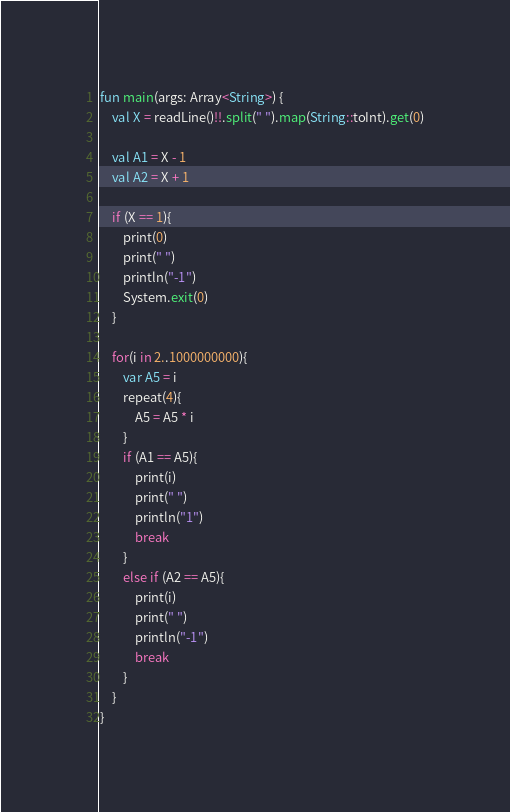Convert code to text. <code><loc_0><loc_0><loc_500><loc_500><_Kotlin_>fun main(args: Array<String>) {
    val X = readLine()!!.split(" ").map(String::toInt).get(0)

    val A1 = X - 1
    val A2 = X + 1

    if (X == 1){
        print(0)
        print(" ")
        println("-1")
        System.exit(0)
    }

    for(i in 2..1000000000){
        var A5 = i
        repeat(4){
            A5 = A5 * i
        }
        if (A1 == A5){
            print(i)
            print(" ")
            println("1")
            break
        }
        else if (A2 == A5){
            print(i)
            print(" ")
            println("-1")
            break
        }
    }
}</code> 